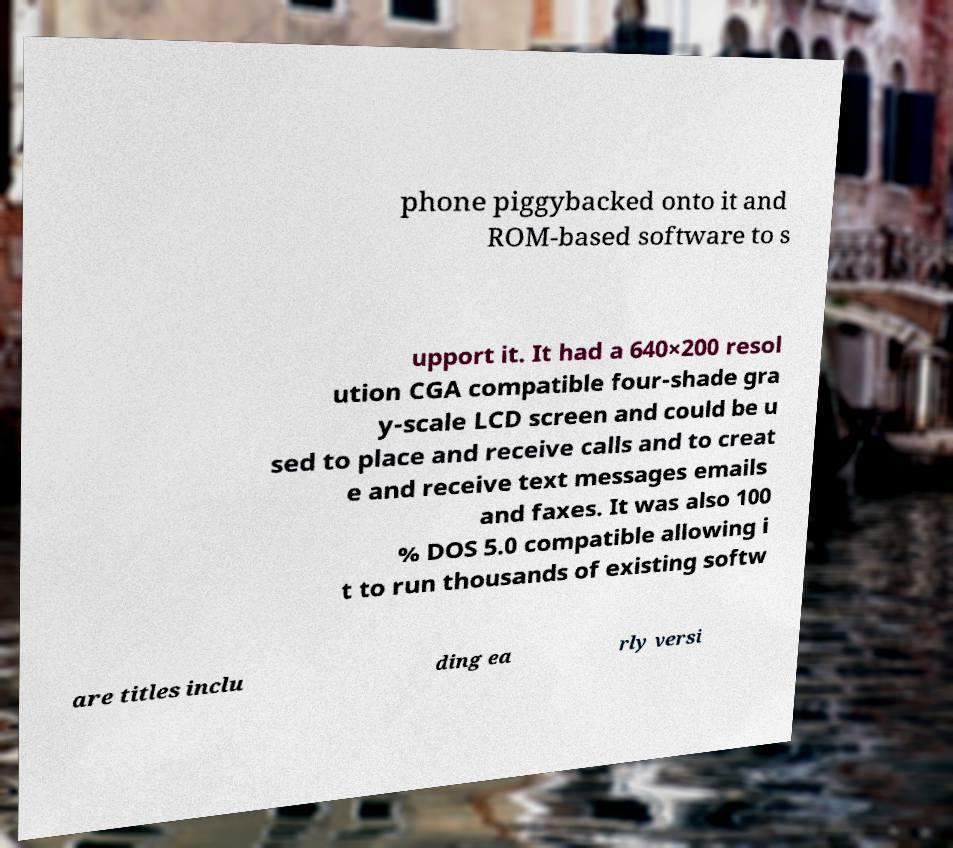Could you assist in decoding the text presented in this image and type it out clearly? phone piggybacked onto it and ROM-based software to s upport it. It had a 640×200 resol ution CGA compatible four-shade gra y-scale LCD screen and could be u sed to place and receive calls and to creat e and receive text messages emails and faxes. It was also 100 % DOS 5.0 compatible allowing i t to run thousands of existing softw are titles inclu ding ea rly versi 